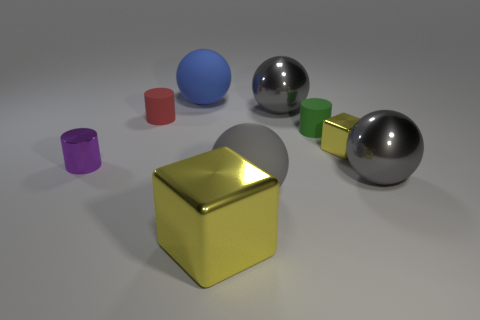Add 1 tiny yellow metallic blocks. How many objects exist? 10 Subtract all red cylinders. How many cylinders are left? 2 Subtract all gray matte balls. How many balls are left? 3 Subtract all cylinders. How many objects are left? 6 Add 2 tiny purple shiny objects. How many tiny purple shiny objects exist? 3 Subtract 0 blue cubes. How many objects are left? 9 Subtract 2 cubes. How many cubes are left? 0 Subtract all purple balls. Subtract all red blocks. How many balls are left? 4 Subtract all gray cubes. How many purple cylinders are left? 1 Subtract all tiny green cylinders. Subtract all blocks. How many objects are left? 6 